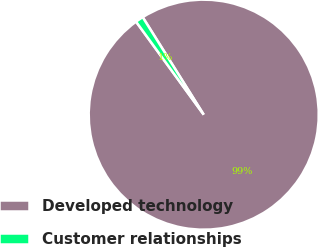Convert chart. <chart><loc_0><loc_0><loc_500><loc_500><pie_chart><fcel>Developed technology<fcel>Customer relationships<nl><fcel>98.89%<fcel>1.11%<nl></chart> 